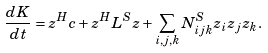Convert formula to latex. <formula><loc_0><loc_0><loc_500><loc_500>\frac { d K } { d t } = z ^ { H } c + z ^ { H } L ^ { S } z + \sum _ { i , j , k } N _ { i j k } ^ { S } z _ { i } z _ { j } z _ { k } .</formula> 